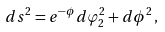Convert formula to latex. <formula><loc_0><loc_0><loc_500><loc_500>d s ^ { 2 } = e ^ { - \phi } d \varphi _ { 2 } ^ { 2 } + d \phi ^ { 2 } \, ,</formula> 